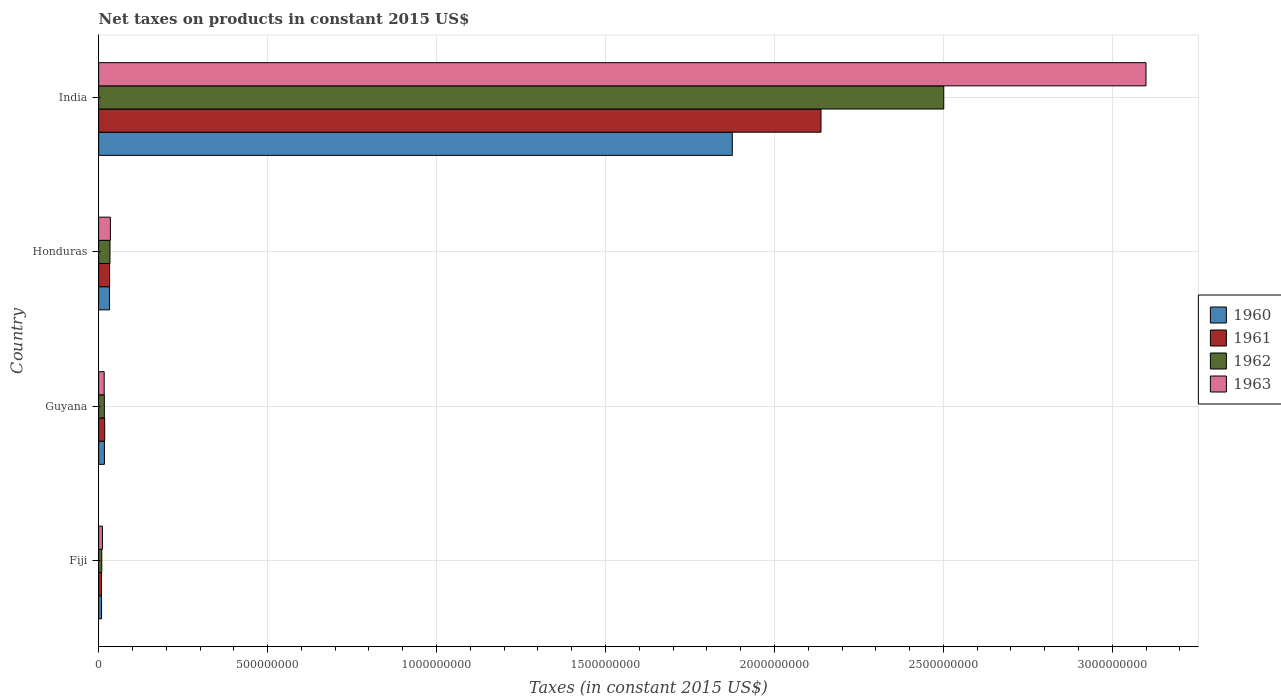How many different coloured bars are there?
Ensure brevity in your answer.  4. How many groups of bars are there?
Offer a very short reply. 4. What is the label of the 1st group of bars from the top?
Offer a terse response. India. In how many cases, is the number of bars for a given country not equal to the number of legend labels?
Your response must be concise. 0. What is the net taxes on products in 1961 in Fiji?
Provide a short and direct response. 8.56e+06. Across all countries, what is the maximum net taxes on products in 1961?
Your response must be concise. 2.14e+09. Across all countries, what is the minimum net taxes on products in 1962?
Provide a succinct answer. 9.32e+06. In which country was the net taxes on products in 1963 minimum?
Provide a short and direct response. Fiji. What is the total net taxes on products in 1961 in the graph?
Your answer should be compact. 2.20e+09. What is the difference between the net taxes on products in 1960 in Honduras and that in India?
Offer a very short reply. -1.84e+09. What is the difference between the net taxes on products in 1962 in Guyana and the net taxes on products in 1960 in Fiji?
Make the answer very short. 8.35e+06. What is the average net taxes on products in 1961 per country?
Provide a succinct answer. 5.49e+08. What is the difference between the net taxes on products in 1962 and net taxes on products in 1961 in Guyana?
Provide a succinct answer. -9.92e+05. What is the ratio of the net taxes on products in 1961 in Honduras to that in India?
Provide a succinct answer. 0.02. What is the difference between the highest and the second highest net taxes on products in 1963?
Provide a succinct answer. 3.06e+09. What is the difference between the highest and the lowest net taxes on products in 1962?
Give a very brief answer. 2.49e+09. Is the sum of the net taxes on products in 1960 in Guyana and Honduras greater than the maximum net taxes on products in 1961 across all countries?
Your answer should be very brief. No. What does the 1st bar from the top in Guyana represents?
Keep it short and to the point. 1963. What does the 2nd bar from the bottom in Guyana represents?
Give a very brief answer. 1961. Is it the case that in every country, the sum of the net taxes on products in 1963 and net taxes on products in 1962 is greater than the net taxes on products in 1961?
Make the answer very short. Yes. How many countries are there in the graph?
Offer a very short reply. 4. What is the difference between two consecutive major ticks on the X-axis?
Provide a succinct answer. 5.00e+08. Are the values on the major ticks of X-axis written in scientific E-notation?
Offer a terse response. No. Does the graph contain any zero values?
Your answer should be compact. No. Does the graph contain grids?
Offer a very short reply. Yes. Where does the legend appear in the graph?
Give a very brief answer. Center right. How are the legend labels stacked?
Offer a terse response. Vertical. What is the title of the graph?
Your answer should be very brief. Net taxes on products in constant 2015 US$. Does "1996" appear as one of the legend labels in the graph?
Keep it short and to the point. No. What is the label or title of the X-axis?
Make the answer very short. Taxes (in constant 2015 US$). What is the Taxes (in constant 2015 US$) of 1960 in Fiji?
Provide a short and direct response. 8.56e+06. What is the Taxes (in constant 2015 US$) in 1961 in Fiji?
Offer a terse response. 8.56e+06. What is the Taxes (in constant 2015 US$) of 1962 in Fiji?
Offer a terse response. 9.32e+06. What is the Taxes (in constant 2015 US$) of 1963 in Fiji?
Your answer should be very brief. 1.12e+07. What is the Taxes (in constant 2015 US$) of 1960 in Guyana?
Provide a short and direct response. 1.71e+07. What is the Taxes (in constant 2015 US$) of 1961 in Guyana?
Give a very brief answer. 1.79e+07. What is the Taxes (in constant 2015 US$) of 1962 in Guyana?
Your answer should be very brief. 1.69e+07. What is the Taxes (in constant 2015 US$) in 1963 in Guyana?
Provide a succinct answer. 1.64e+07. What is the Taxes (in constant 2015 US$) in 1960 in Honduras?
Offer a very short reply. 3.22e+07. What is the Taxes (in constant 2015 US$) in 1961 in Honduras?
Offer a terse response. 3.25e+07. What is the Taxes (in constant 2015 US$) of 1962 in Honduras?
Your answer should be very brief. 3.36e+07. What is the Taxes (in constant 2015 US$) in 1963 in Honduras?
Keep it short and to the point. 3.48e+07. What is the Taxes (in constant 2015 US$) in 1960 in India?
Give a very brief answer. 1.88e+09. What is the Taxes (in constant 2015 US$) in 1961 in India?
Provide a succinct answer. 2.14e+09. What is the Taxes (in constant 2015 US$) of 1962 in India?
Offer a terse response. 2.50e+09. What is the Taxes (in constant 2015 US$) in 1963 in India?
Make the answer very short. 3.10e+09. Across all countries, what is the maximum Taxes (in constant 2015 US$) of 1960?
Your response must be concise. 1.88e+09. Across all countries, what is the maximum Taxes (in constant 2015 US$) in 1961?
Give a very brief answer. 2.14e+09. Across all countries, what is the maximum Taxes (in constant 2015 US$) in 1962?
Offer a very short reply. 2.50e+09. Across all countries, what is the maximum Taxes (in constant 2015 US$) of 1963?
Provide a short and direct response. 3.10e+09. Across all countries, what is the minimum Taxes (in constant 2015 US$) in 1960?
Ensure brevity in your answer.  8.56e+06. Across all countries, what is the minimum Taxes (in constant 2015 US$) in 1961?
Your answer should be very brief. 8.56e+06. Across all countries, what is the minimum Taxes (in constant 2015 US$) in 1962?
Offer a terse response. 9.32e+06. Across all countries, what is the minimum Taxes (in constant 2015 US$) in 1963?
Your answer should be compact. 1.12e+07. What is the total Taxes (in constant 2015 US$) in 1960 in the graph?
Your answer should be compact. 1.93e+09. What is the total Taxes (in constant 2015 US$) of 1961 in the graph?
Give a very brief answer. 2.20e+09. What is the total Taxes (in constant 2015 US$) in 1962 in the graph?
Your answer should be compact. 2.56e+09. What is the total Taxes (in constant 2015 US$) in 1963 in the graph?
Provide a short and direct response. 3.16e+09. What is the difference between the Taxes (in constant 2015 US$) in 1960 in Fiji and that in Guyana?
Make the answer very short. -8.59e+06. What is the difference between the Taxes (in constant 2015 US$) of 1961 in Fiji and that in Guyana?
Provide a short and direct response. -9.34e+06. What is the difference between the Taxes (in constant 2015 US$) in 1962 in Fiji and that in Guyana?
Offer a terse response. -7.60e+06. What is the difference between the Taxes (in constant 2015 US$) in 1963 in Fiji and that in Guyana?
Provide a short and direct response. -5.24e+06. What is the difference between the Taxes (in constant 2015 US$) of 1960 in Fiji and that in Honduras?
Ensure brevity in your answer.  -2.37e+07. What is the difference between the Taxes (in constant 2015 US$) in 1961 in Fiji and that in Honduras?
Offer a terse response. -2.39e+07. What is the difference between the Taxes (in constant 2015 US$) of 1962 in Fiji and that in Honduras?
Give a very brief answer. -2.43e+07. What is the difference between the Taxes (in constant 2015 US$) in 1963 in Fiji and that in Honduras?
Your response must be concise. -2.36e+07. What is the difference between the Taxes (in constant 2015 US$) of 1960 in Fiji and that in India?
Give a very brief answer. -1.87e+09. What is the difference between the Taxes (in constant 2015 US$) of 1961 in Fiji and that in India?
Keep it short and to the point. -2.13e+09. What is the difference between the Taxes (in constant 2015 US$) in 1962 in Fiji and that in India?
Make the answer very short. -2.49e+09. What is the difference between the Taxes (in constant 2015 US$) in 1963 in Fiji and that in India?
Offer a very short reply. -3.09e+09. What is the difference between the Taxes (in constant 2015 US$) of 1960 in Guyana and that in Honduras?
Ensure brevity in your answer.  -1.51e+07. What is the difference between the Taxes (in constant 2015 US$) of 1961 in Guyana and that in Honduras?
Offer a terse response. -1.46e+07. What is the difference between the Taxes (in constant 2015 US$) of 1962 in Guyana and that in Honduras?
Provide a succinct answer. -1.67e+07. What is the difference between the Taxes (in constant 2015 US$) in 1963 in Guyana and that in Honduras?
Your answer should be very brief. -1.84e+07. What is the difference between the Taxes (in constant 2015 US$) in 1960 in Guyana and that in India?
Ensure brevity in your answer.  -1.86e+09. What is the difference between the Taxes (in constant 2015 US$) of 1961 in Guyana and that in India?
Ensure brevity in your answer.  -2.12e+09. What is the difference between the Taxes (in constant 2015 US$) of 1962 in Guyana and that in India?
Your answer should be very brief. -2.48e+09. What is the difference between the Taxes (in constant 2015 US$) in 1963 in Guyana and that in India?
Offer a very short reply. -3.08e+09. What is the difference between the Taxes (in constant 2015 US$) of 1960 in Honduras and that in India?
Make the answer very short. -1.84e+09. What is the difference between the Taxes (in constant 2015 US$) in 1961 in Honduras and that in India?
Offer a very short reply. -2.11e+09. What is the difference between the Taxes (in constant 2015 US$) of 1962 in Honduras and that in India?
Keep it short and to the point. -2.47e+09. What is the difference between the Taxes (in constant 2015 US$) in 1963 in Honduras and that in India?
Provide a short and direct response. -3.06e+09. What is the difference between the Taxes (in constant 2015 US$) of 1960 in Fiji and the Taxes (in constant 2015 US$) of 1961 in Guyana?
Ensure brevity in your answer.  -9.34e+06. What is the difference between the Taxes (in constant 2015 US$) of 1960 in Fiji and the Taxes (in constant 2015 US$) of 1962 in Guyana?
Make the answer very short. -8.35e+06. What is the difference between the Taxes (in constant 2015 US$) of 1960 in Fiji and the Taxes (in constant 2015 US$) of 1963 in Guyana?
Provide a succinct answer. -7.89e+06. What is the difference between the Taxes (in constant 2015 US$) in 1961 in Fiji and the Taxes (in constant 2015 US$) in 1962 in Guyana?
Provide a short and direct response. -8.35e+06. What is the difference between the Taxes (in constant 2015 US$) in 1961 in Fiji and the Taxes (in constant 2015 US$) in 1963 in Guyana?
Ensure brevity in your answer.  -7.89e+06. What is the difference between the Taxes (in constant 2015 US$) in 1962 in Fiji and the Taxes (in constant 2015 US$) in 1963 in Guyana?
Your answer should be very brief. -7.13e+06. What is the difference between the Taxes (in constant 2015 US$) of 1960 in Fiji and the Taxes (in constant 2015 US$) of 1961 in Honduras?
Make the answer very short. -2.39e+07. What is the difference between the Taxes (in constant 2015 US$) of 1960 in Fiji and the Taxes (in constant 2015 US$) of 1962 in Honduras?
Give a very brief answer. -2.51e+07. What is the difference between the Taxes (in constant 2015 US$) in 1960 in Fiji and the Taxes (in constant 2015 US$) in 1963 in Honduras?
Ensure brevity in your answer.  -2.62e+07. What is the difference between the Taxes (in constant 2015 US$) in 1961 in Fiji and the Taxes (in constant 2015 US$) in 1962 in Honduras?
Your answer should be very brief. -2.51e+07. What is the difference between the Taxes (in constant 2015 US$) of 1961 in Fiji and the Taxes (in constant 2015 US$) of 1963 in Honduras?
Keep it short and to the point. -2.62e+07. What is the difference between the Taxes (in constant 2015 US$) in 1962 in Fiji and the Taxes (in constant 2015 US$) in 1963 in Honduras?
Offer a very short reply. -2.55e+07. What is the difference between the Taxes (in constant 2015 US$) in 1960 in Fiji and the Taxes (in constant 2015 US$) in 1961 in India?
Provide a short and direct response. -2.13e+09. What is the difference between the Taxes (in constant 2015 US$) in 1960 in Fiji and the Taxes (in constant 2015 US$) in 1962 in India?
Provide a succinct answer. -2.49e+09. What is the difference between the Taxes (in constant 2015 US$) in 1960 in Fiji and the Taxes (in constant 2015 US$) in 1963 in India?
Offer a very short reply. -3.09e+09. What is the difference between the Taxes (in constant 2015 US$) of 1961 in Fiji and the Taxes (in constant 2015 US$) of 1962 in India?
Your answer should be very brief. -2.49e+09. What is the difference between the Taxes (in constant 2015 US$) of 1961 in Fiji and the Taxes (in constant 2015 US$) of 1963 in India?
Offer a very short reply. -3.09e+09. What is the difference between the Taxes (in constant 2015 US$) of 1962 in Fiji and the Taxes (in constant 2015 US$) of 1963 in India?
Offer a terse response. -3.09e+09. What is the difference between the Taxes (in constant 2015 US$) in 1960 in Guyana and the Taxes (in constant 2015 US$) in 1961 in Honduras?
Offer a terse response. -1.54e+07. What is the difference between the Taxes (in constant 2015 US$) of 1960 in Guyana and the Taxes (in constant 2015 US$) of 1962 in Honduras?
Offer a very short reply. -1.65e+07. What is the difference between the Taxes (in constant 2015 US$) of 1960 in Guyana and the Taxes (in constant 2015 US$) of 1963 in Honduras?
Ensure brevity in your answer.  -1.77e+07. What is the difference between the Taxes (in constant 2015 US$) in 1961 in Guyana and the Taxes (in constant 2015 US$) in 1962 in Honduras?
Keep it short and to the point. -1.57e+07. What is the difference between the Taxes (in constant 2015 US$) in 1961 in Guyana and the Taxes (in constant 2015 US$) in 1963 in Honduras?
Offer a terse response. -1.69e+07. What is the difference between the Taxes (in constant 2015 US$) of 1962 in Guyana and the Taxes (in constant 2015 US$) of 1963 in Honduras?
Offer a terse response. -1.79e+07. What is the difference between the Taxes (in constant 2015 US$) in 1960 in Guyana and the Taxes (in constant 2015 US$) in 1961 in India?
Your answer should be very brief. -2.12e+09. What is the difference between the Taxes (in constant 2015 US$) of 1960 in Guyana and the Taxes (in constant 2015 US$) of 1962 in India?
Provide a succinct answer. -2.48e+09. What is the difference between the Taxes (in constant 2015 US$) in 1960 in Guyana and the Taxes (in constant 2015 US$) in 1963 in India?
Provide a short and direct response. -3.08e+09. What is the difference between the Taxes (in constant 2015 US$) of 1961 in Guyana and the Taxes (in constant 2015 US$) of 1962 in India?
Keep it short and to the point. -2.48e+09. What is the difference between the Taxes (in constant 2015 US$) in 1961 in Guyana and the Taxes (in constant 2015 US$) in 1963 in India?
Provide a succinct answer. -3.08e+09. What is the difference between the Taxes (in constant 2015 US$) in 1962 in Guyana and the Taxes (in constant 2015 US$) in 1963 in India?
Give a very brief answer. -3.08e+09. What is the difference between the Taxes (in constant 2015 US$) of 1960 in Honduras and the Taxes (in constant 2015 US$) of 1961 in India?
Offer a very short reply. -2.11e+09. What is the difference between the Taxes (in constant 2015 US$) in 1960 in Honduras and the Taxes (in constant 2015 US$) in 1962 in India?
Offer a terse response. -2.47e+09. What is the difference between the Taxes (in constant 2015 US$) in 1960 in Honduras and the Taxes (in constant 2015 US$) in 1963 in India?
Ensure brevity in your answer.  -3.07e+09. What is the difference between the Taxes (in constant 2015 US$) in 1961 in Honduras and the Taxes (in constant 2015 US$) in 1962 in India?
Make the answer very short. -2.47e+09. What is the difference between the Taxes (in constant 2015 US$) in 1961 in Honduras and the Taxes (in constant 2015 US$) in 1963 in India?
Offer a terse response. -3.07e+09. What is the difference between the Taxes (in constant 2015 US$) of 1962 in Honduras and the Taxes (in constant 2015 US$) of 1963 in India?
Your answer should be very brief. -3.07e+09. What is the average Taxes (in constant 2015 US$) of 1960 per country?
Provide a succinct answer. 4.83e+08. What is the average Taxes (in constant 2015 US$) of 1961 per country?
Your answer should be very brief. 5.49e+08. What is the average Taxes (in constant 2015 US$) of 1962 per country?
Provide a short and direct response. 6.40e+08. What is the average Taxes (in constant 2015 US$) in 1963 per country?
Offer a terse response. 7.91e+08. What is the difference between the Taxes (in constant 2015 US$) of 1960 and Taxes (in constant 2015 US$) of 1961 in Fiji?
Offer a very short reply. 0. What is the difference between the Taxes (in constant 2015 US$) of 1960 and Taxes (in constant 2015 US$) of 1962 in Fiji?
Offer a terse response. -7.56e+05. What is the difference between the Taxes (in constant 2015 US$) in 1960 and Taxes (in constant 2015 US$) in 1963 in Fiji?
Offer a terse response. -2.64e+06. What is the difference between the Taxes (in constant 2015 US$) of 1961 and Taxes (in constant 2015 US$) of 1962 in Fiji?
Keep it short and to the point. -7.56e+05. What is the difference between the Taxes (in constant 2015 US$) in 1961 and Taxes (in constant 2015 US$) in 1963 in Fiji?
Your answer should be very brief. -2.64e+06. What is the difference between the Taxes (in constant 2015 US$) in 1962 and Taxes (in constant 2015 US$) in 1963 in Fiji?
Provide a short and direct response. -1.89e+06. What is the difference between the Taxes (in constant 2015 US$) of 1960 and Taxes (in constant 2015 US$) of 1961 in Guyana?
Your answer should be compact. -7.58e+05. What is the difference between the Taxes (in constant 2015 US$) of 1960 and Taxes (in constant 2015 US$) of 1962 in Guyana?
Your answer should be compact. 2.33e+05. What is the difference between the Taxes (in constant 2015 US$) of 1960 and Taxes (in constant 2015 US$) of 1963 in Guyana?
Offer a terse response. 7.00e+05. What is the difference between the Taxes (in constant 2015 US$) of 1961 and Taxes (in constant 2015 US$) of 1962 in Guyana?
Offer a very short reply. 9.92e+05. What is the difference between the Taxes (in constant 2015 US$) of 1961 and Taxes (in constant 2015 US$) of 1963 in Guyana?
Give a very brief answer. 1.46e+06. What is the difference between the Taxes (in constant 2015 US$) in 1962 and Taxes (in constant 2015 US$) in 1963 in Guyana?
Keep it short and to the point. 4.67e+05. What is the difference between the Taxes (in constant 2015 US$) in 1960 and Taxes (in constant 2015 US$) in 1962 in Honduras?
Offer a terse response. -1.40e+06. What is the difference between the Taxes (in constant 2015 US$) of 1960 and Taxes (in constant 2015 US$) of 1963 in Honduras?
Offer a terse response. -2.55e+06. What is the difference between the Taxes (in constant 2015 US$) in 1961 and Taxes (in constant 2015 US$) in 1962 in Honduras?
Ensure brevity in your answer.  -1.15e+06. What is the difference between the Taxes (in constant 2015 US$) in 1961 and Taxes (in constant 2015 US$) in 1963 in Honduras?
Keep it short and to the point. -2.30e+06. What is the difference between the Taxes (in constant 2015 US$) in 1962 and Taxes (in constant 2015 US$) in 1963 in Honduras?
Make the answer very short. -1.15e+06. What is the difference between the Taxes (in constant 2015 US$) of 1960 and Taxes (in constant 2015 US$) of 1961 in India?
Your answer should be compact. -2.63e+08. What is the difference between the Taxes (in constant 2015 US$) in 1960 and Taxes (in constant 2015 US$) in 1962 in India?
Make the answer very short. -6.26e+08. What is the difference between the Taxes (in constant 2015 US$) in 1960 and Taxes (in constant 2015 US$) in 1963 in India?
Provide a succinct answer. -1.22e+09. What is the difference between the Taxes (in constant 2015 US$) of 1961 and Taxes (in constant 2015 US$) of 1962 in India?
Provide a short and direct response. -3.63e+08. What is the difference between the Taxes (in constant 2015 US$) in 1961 and Taxes (in constant 2015 US$) in 1963 in India?
Your answer should be very brief. -9.62e+08. What is the difference between the Taxes (in constant 2015 US$) in 1962 and Taxes (in constant 2015 US$) in 1963 in India?
Ensure brevity in your answer.  -5.99e+08. What is the ratio of the Taxes (in constant 2015 US$) of 1960 in Fiji to that in Guyana?
Keep it short and to the point. 0.5. What is the ratio of the Taxes (in constant 2015 US$) in 1961 in Fiji to that in Guyana?
Provide a short and direct response. 0.48. What is the ratio of the Taxes (in constant 2015 US$) of 1962 in Fiji to that in Guyana?
Your answer should be very brief. 0.55. What is the ratio of the Taxes (in constant 2015 US$) in 1963 in Fiji to that in Guyana?
Keep it short and to the point. 0.68. What is the ratio of the Taxes (in constant 2015 US$) of 1960 in Fiji to that in Honduras?
Give a very brief answer. 0.27. What is the ratio of the Taxes (in constant 2015 US$) in 1961 in Fiji to that in Honduras?
Your response must be concise. 0.26. What is the ratio of the Taxes (in constant 2015 US$) of 1962 in Fiji to that in Honduras?
Your answer should be compact. 0.28. What is the ratio of the Taxes (in constant 2015 US$) of 1963 in Fiji to that in Honduras?
Make the answer very short. 0.32. What is the ratio of the Taxes (in constant 2015 US$) in 1960 in Fiji to that in India?
Your answer should be compact. 0. What is the ratio of the Taxes (in constant 2015 US$) in 1961 in Fiji to that in India?
Ensure brevity in your answer.  0. What is the ratio of the Taxes (in constant 2015 US$) of 1962 in Fiji to that in India?
Offer a terse response. 0. What is the ratio of the Taxes (in constant 2015 US$) in 1963 in Fiji to that in India?
Give a very brief answer. 0. What is the ratio of the Taxes (in constant 2015 US$) in 1960 in Guyana to that in Honduras?
Offer a very short reply. 0.53. What is the ratio of the Taxes (in constant 2015 US$) of 1961 in Guyana to that in Honduras?
Ensure brevity in your answer.  0.55. What is the ratio of the Taxes (in constant 2015 US$) of 1962 in Guyana to that in Honduras?
Your response must be concise. 0.5. What is the ratio of the Taxes (in constant 2015 US$) of 1963 in Guyana to that in Honduras?
Keep it short and to the point. 0.47. What is the ratio of the Taxes (in constant 2015 US$) of 1960 in Guyana to that in India?
Your response must be concise. 0.01. What is the ratio of the Taxes (in constant 2015 US$) of 1961 in Guyana to that in India?
Make the answer very short. 0.01. What is the ratio of the Taxes (in constant 2015 US$) of 1962 in Guyana to that in India?
Ensure brevity in your answer.  0.01. What is the ratio of the Taxes (in constant 2015 US$) of 1963 in Guyana to that in India?
Offer a terse response. 0.01. What is the ratio of the Taxes (in constant 2015 US$) in 1960 in Honduras to that in India?
Provide a short and direct response. 0.02. What is the ratio of the Taxes (in constant 2015 US$) in 1961 in Honduras to that in India?
Provide a succinct answer. 0.02. What is the ratio of the Taxes (in constant 2015 US$) in 1962 in Honduras to that in India?
Your response must be concise. 0.01. What is the ratio of the Taxes (in constant 2015 US$) in 1963 in Honduras to that in India?
Your response must be concise. 0.01. What is the difference between the highest and the second highest Taxes (in constant 2015 US$) of 1960?
Your answer should be very brief. 1.84e+09. What is the difference between the highest and the second highest Taxes (in constant 2015 US$) in 1961?
Your response must be concise. 2.11e+09. What is the difference between the highest and the second highest Taxes (in constant 2015 US$) of 1962?
Your response must be concise. 2.47e+09. What is the difference between the highest and the second highest Taxes (in constant 2015 US$) of 1963?
Offer a terse response. 3.06e+09. What is the difference between the highest and the lowest Taxes (in constant 2015 US$) in 1960?
Provide a succinct answer. 1.87e+09. What is the difference between the highest and the lowest Taxes (in constant 2015 US$) of 1961?
Your response must be concise. 2.13e+09. What is the difference between the highest and the lowest Taxes (in constant 2015 US$) in 1962?
Your response must be concise. 2.49e+09. What is the difference between the highest and the lowest Taxes (in constant 2015 US$) of 1963?
Give a very brief answer. 3.09e+09. 